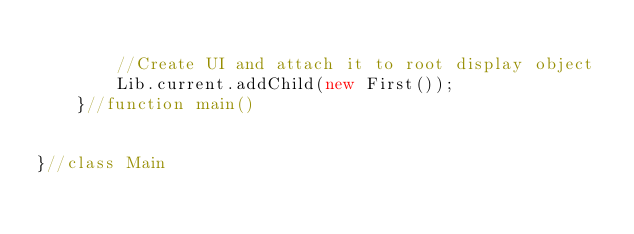<code> <loc_0><loc_0><loc_500><loc_500><_Haxe_>
        //Create UI and attach it to root display object
        Lib.current.addChild(new First());
    }//function main()


}//class Main
</code> 